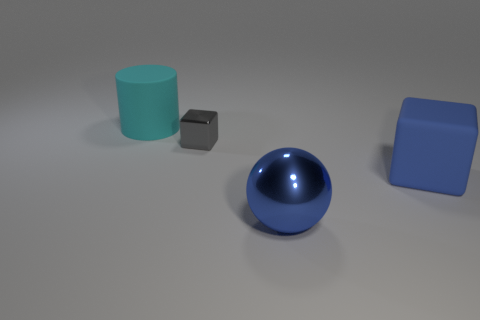Is there anything else that has the same size as the metal block?
Make the answer very short. No. Are there any other things that have the same material as the sphere?
Make the answer very short. Yes. What number of other things are there of the same material as the large blue sphere
Offer a terse response. 1. There is a big rubber object that is to the right of the big blue metal thing; is there a big blue block behind it?
Ensure brevity in your answer.  No. Are there any other things that have the same shape as the small gray thing?
Your answer should be very brief. Yes. What color is the shiny thing that is the same shape as the blue rubber object?
Offer a terse response. Gray. What is the size of the gray metallic cube?
Your answer should be very brief. Small. Is the number of cyan matte objects that are in front of the tiny gray object less than the number of cubes?
Offer a terse response. Yes. Are the big sphere and the large object that is behind the blue block made of the same material?
Ensure brevity in your answer.  No. There is a metal thing behind the block that is right of the large blue metal thing; is there a blue metal ball that is on the left side of it?
Offer a terse response. No. 